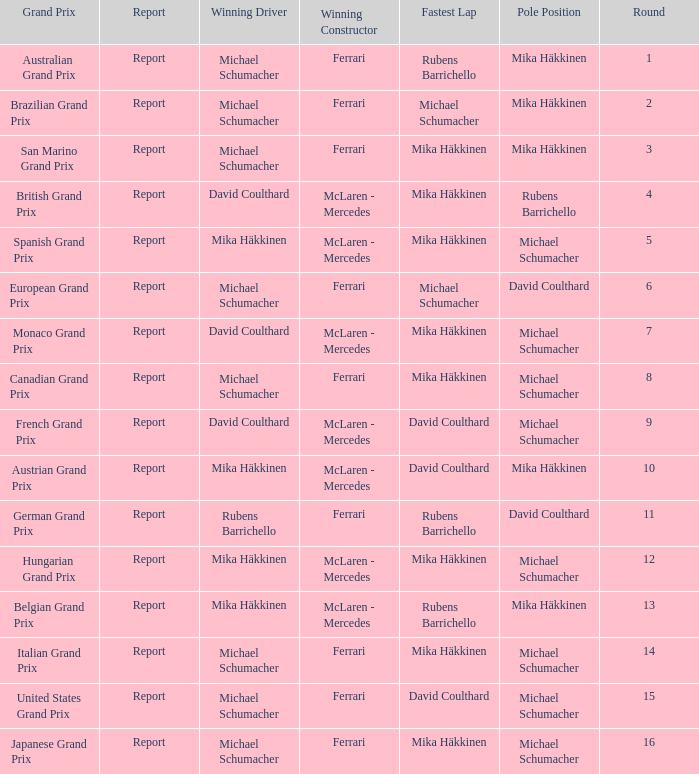Which round had Michael Schumacher in the pole position, David Coulthard with the fastest lap, and McLaren - Mercedes as the winning constructor? 1.0. 